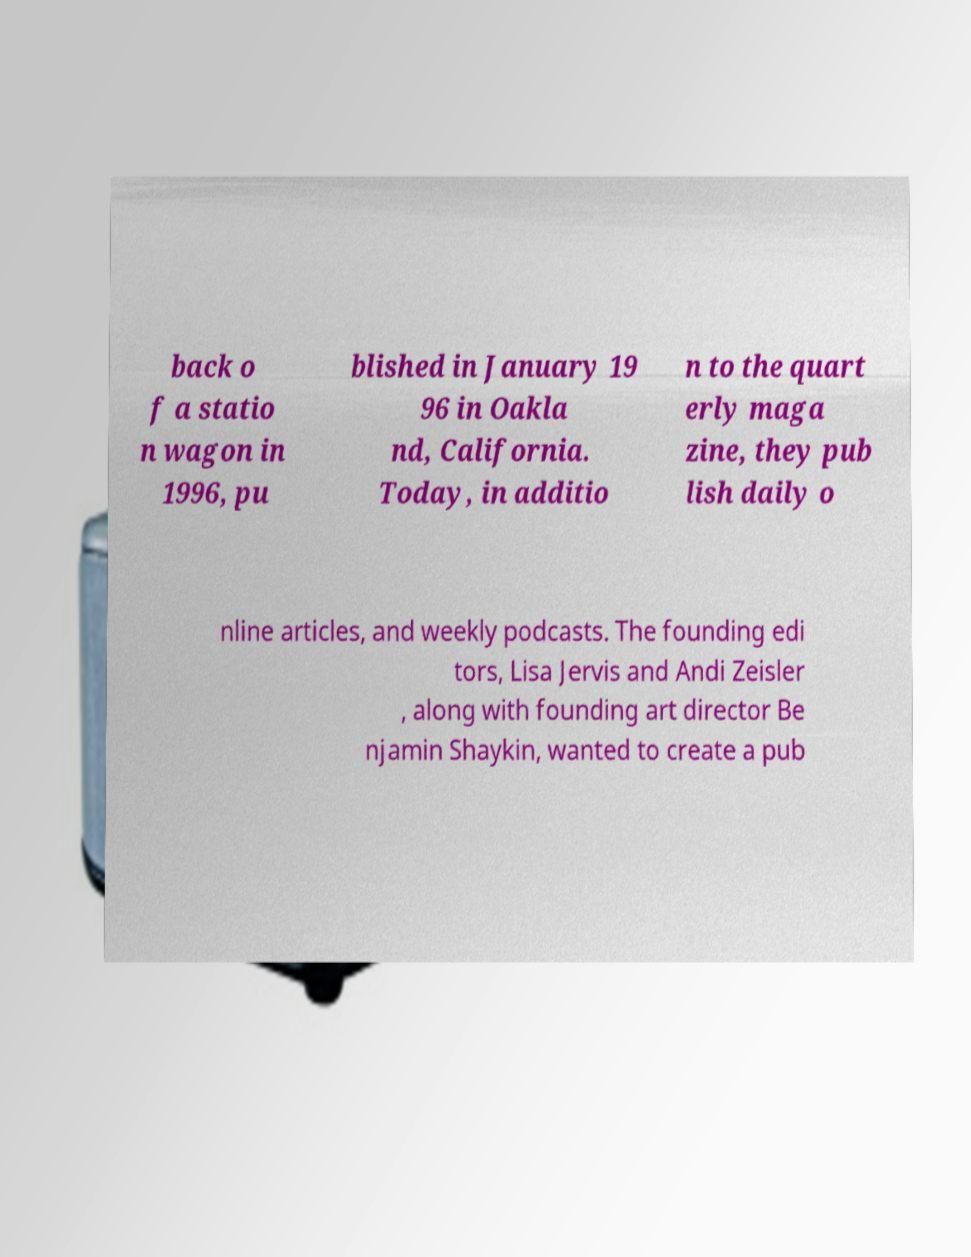Could you assist in decoding the text presented in this image and type it out clearly? back o f a statio n wagon in 1996, pu blished in January 19 96 in Oakla nd, California. Today, in additio n to the quart erly maga zine, they pub lish daily o nline articles, and weekly podcasts. The founding edi tors, Lisa Jervis and Andi Zeisler , along with founding art director Be njamin Shaykin, wanted to create a pub 